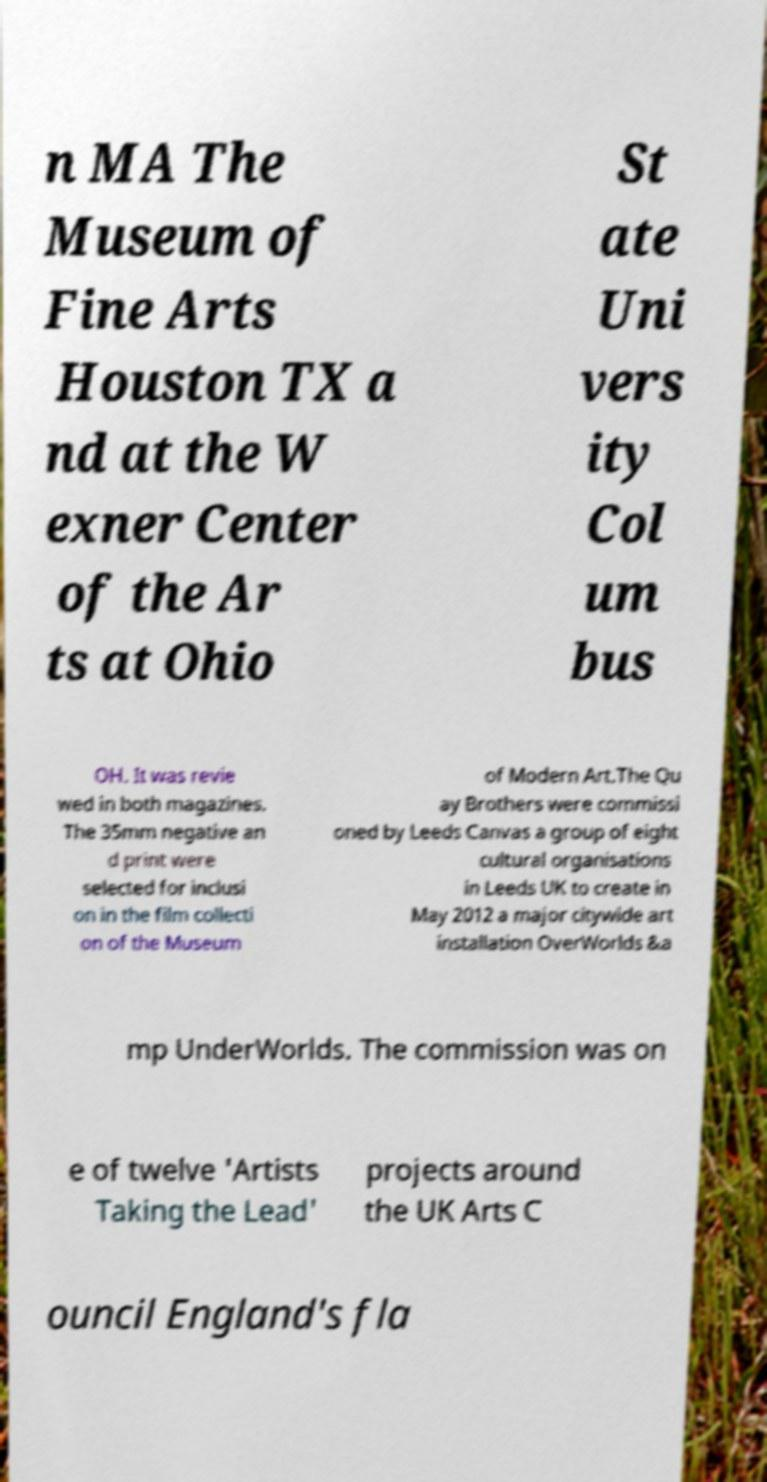There's text embedded in this image that I need extracted. Can you transcribe it verbatim? n MA The Museum of Fine Arts Houston TX a nd at the W exner Center of the Ar ts at Ohio St ate Uni vers ity Col um bus OH. It was revie wed in both magazines. The 35mm negative an d print were selected for inclusi on in the film collecti on of the Museum of Modern Art.The Qu ay Brothers were commissi oned by Leeds Canvas a group of eight cultural organisations in Leeds UK to create in May 2012 a major citywide art installation OverWorlds &a mp UnderWorlds. The commission was on e of twelve 'Artists Taking the Lead' projects around the UK Arts C ouncil England's fla 